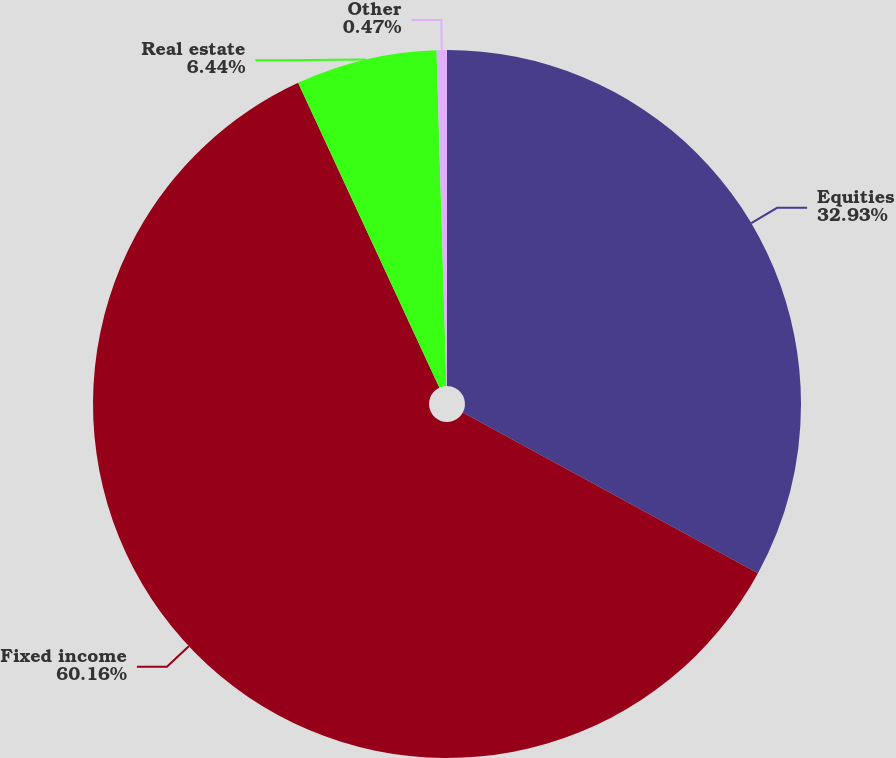Convert chart to OTSL. <chart><loc_0><loc_0><loc_500><loc_500><pie_chart><fcel>Equities<fcel>Fixed income<fcel>Real estate<fcel>Other<nl><fcel>32.93%<fcel>60.16%<fcel>6.44%<fcel>0.47%<nl></chart> 